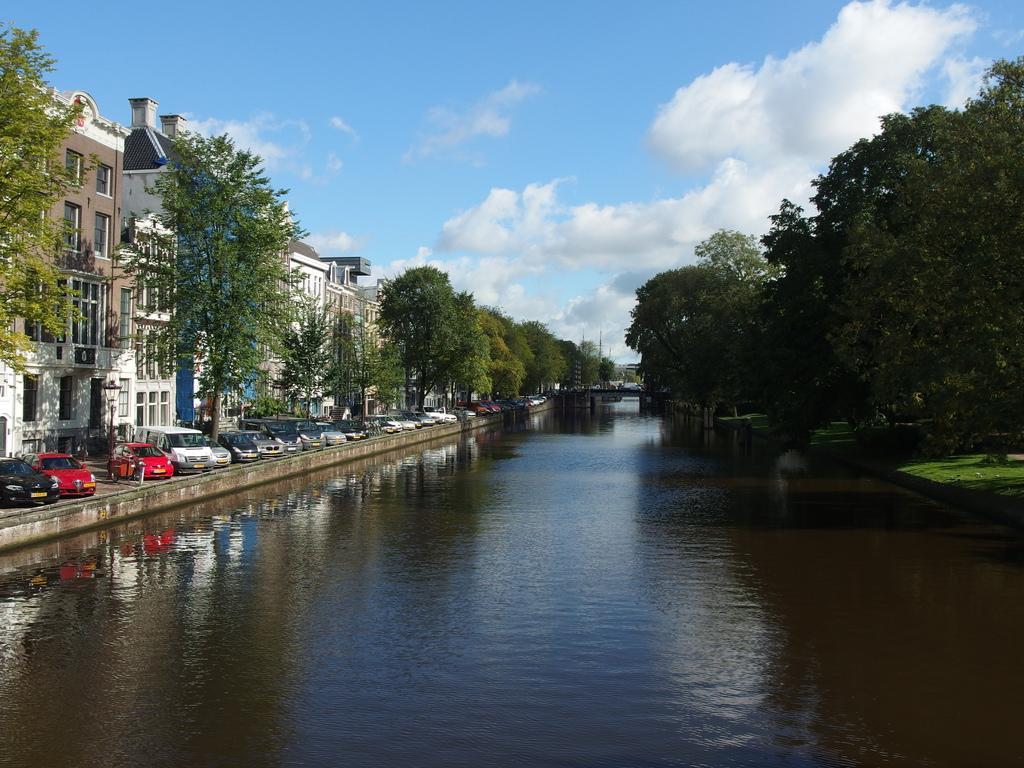How would you summarize this image in a sentence or two? At the bottom of the picture, we see water and this water might be in the canal. On the right side, we see the trees and grass. On the left side, we see the trees, buildings, poles and vehicles are parked on the road. At the top, we see the clouds and the sky, which is blue in color. 